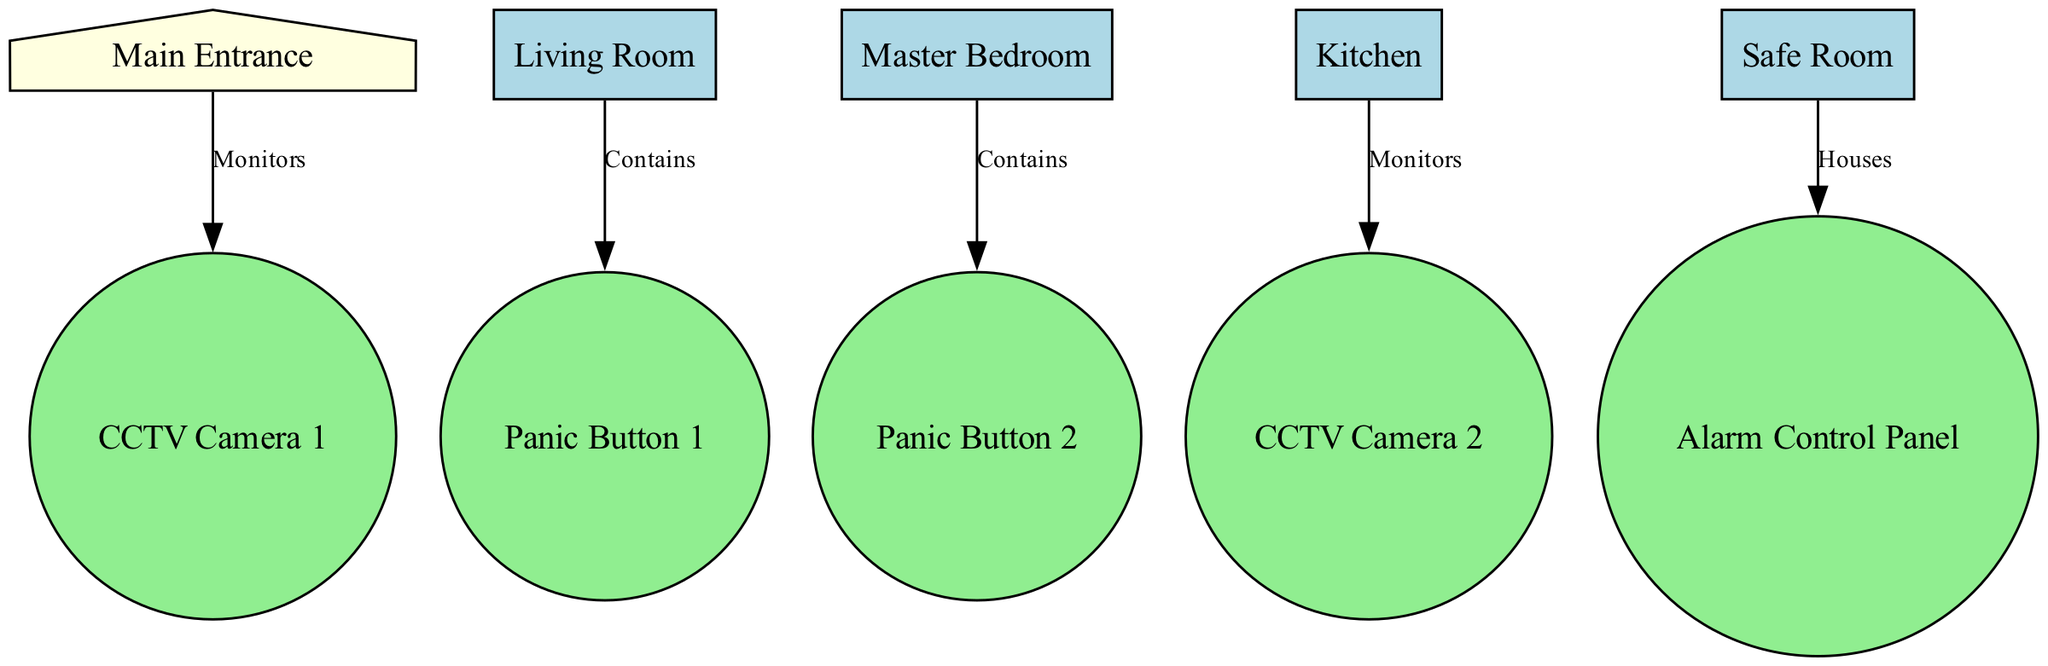What is the panic button located in the living room labeled as? The diagram indicates that the panic button located in the living room is labeled as "Panic Button 1." This can be found by identifying the nodes and edges that connect the living room to the panic button.
Answer: Panic Button 1 How many CCTV cameras are shown in the diagram? By examining the nodes present in the diagram, there are two nodes labeled as CCTV cameras: "CCTV Camera 1" and "CCTV Camera 2." Thus, the total count is two.
Answer: 2 Which room contains Panic Button 2? The diagram specifies that Panic Button 2 is contained within the bedroom. This connection is illustrated by the edge that links the bedroom to Panic Button 2.
Answer: Bedroom What does the safe room house? The safe room in the diagram is indicated to house the "Alarm Control Panel." This information is derived from the edge that connects the safe room to the alarm panel, explicitly stating the relationship.
Answer: Alarm Control Panel Which entrance is monitored by CCTV Camera 1? The diagram shows that CCTV Camera 1 monitors the main entrance, as illustrated by the edge connecting the main entrance to the camera. This is a direct correlation based on the connections depicted in the diagram.
Answer: Main Entrance Where is CCTV Camera 2 located in relation to the kitchen? CCTV Camera 2 is shown to monitor the kitchen. This relationship is explicitly mentioned in the edge that connects the kitchen to CCTV Camera 2.
Answer: Monitors What type of security device is Panic Button 1? By analyzing the nodes in the diagram, Panic Button 1 is identified as a security device. This classification is derived from the type assigned to the node in the diagram's data structure.
Answer: Security Device Which device is located in the living room? The diagram indicates that the living room contains Panic Button 1. This can be verified by looking at the edges in the diagram connecting the living room to the panic button.
Answer: Panic Button 1 